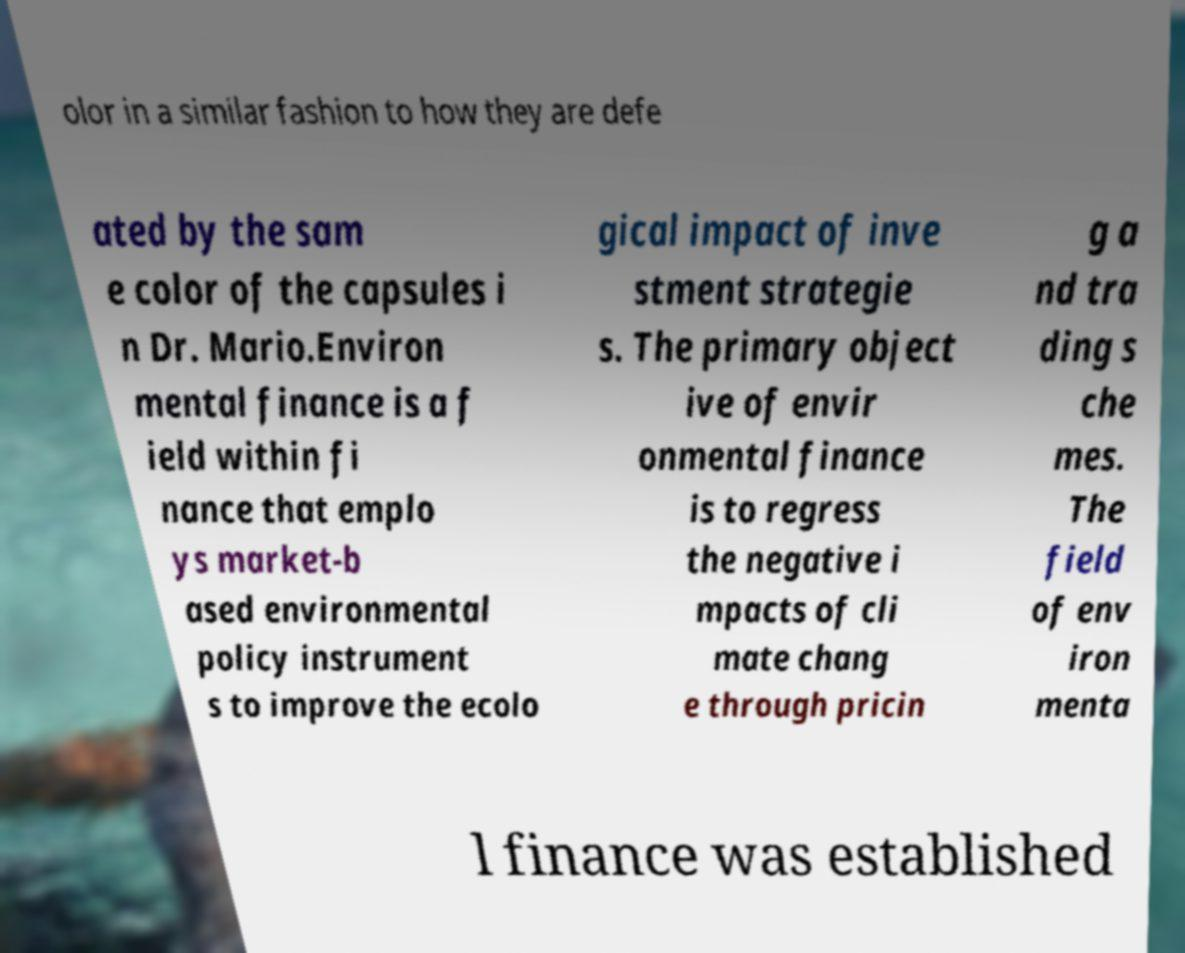Could you assist in decoding the text presented in this image and type it out clearly? olor in a similar fashion to how they are defe ated by the sam e color of the capsules i n Dr. Mario.Environ mental finance is a f ield within fi nance that emplo ys market-b ased environmental policy instrument s to improve the ecolo gical impact of inve stment strategie s. The primary object ive of envir onmental finance is to regress the negative i mpacts of cli mate chang e through pricin g a nd tra ding s che mes. The field of env iron menta l finance was established 